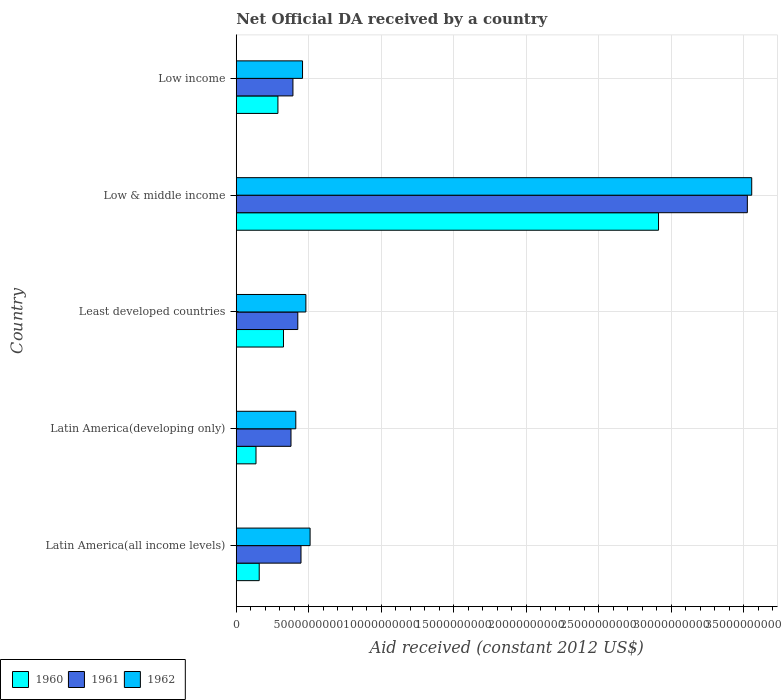How many groups of bars are there?
Your response must be concise. 5. Are the number of bars per tick equal to the number of legend labels?
Your response must be concise. Yes. What is the label of the 3rd group of bars from the top?
Keep it short and to the point. Least developed countries. In how many cases, is the number of bars for a given country not equal to the number of legend labels?
Your answer should be compact. 0. What is the net official development assistance aid received in 1962 in Low & middle income?
Provide a short and direct response. 3.56e+1. Across all countries, what is the maximum net official development assistance aid received in 1960?
Make the answer very short. 2.91e+1. Across all countries, what is the minimum net official development assistance aid received in 1960?
Make the answer very short. 1.36e+09. In which country was the net official development assistance aid received in 1961 maximum?
Give a very brief answer. Low & middle income. In which country was the net official development assistance aid received in 1960 minimum?
Ensure brevity in your answer.  Latin America(developing only). What is the total net official development assistance aid received in 1962 in the graph?
Your answer should be compact. 5.41e+1. What is the difference between the net official development assistance aid received in 1960 in Latin America(all income levels) and that in Least developed countries?
Make the answer very short. -1.68e+09. What is the difference between the net official development assistance aid received in 1962 in Latin America(developing only) and the net official development assistance aid received in 1961 in Low income?
Make the answer very short. 1.98e+08. What is the average net official development assistance aid received in 1961 per country?
Provide a succinct answer. 1.03e+1. What is the difference between the net official development assistance aid received in 1962 and net official development assistance aid received in 1960 in Low income?
Your answer should be compact. 1.70e+09. In how many countries, is the net official development assistance aid received in 1962 greater than 18000000000 US$?
Your response must be concise. 1. What is the ratio of the net official development assistance aid received in 1962 in Latin America(developing only) to that in Least developed countries?
Your response must be concise. 0.86. Is the net official development assistance aid received in 1962 in Latin America(developing only) less than that in Least developed countries?
Keep it short and to the point. Yes. Is the difference between the net official development assistance aid received in 1962 in Latin America(all income levels) and Low income greater than the difference between the net official development assistance aid received in 1960 in Latin America(all income levels) and Low income?
Offer a very short reply. Yes. What is the difference between the highest and the second highest net official development assistance aid received in 1962?
Keep it short and to the point. 3.05e+1. What is the difference between the highest and the lowest net official development assistance aid received in 1960?
Make the answer very short. 2.78e+1. In how many countries, is the net official development assistance aid received in 1960 greater than the average net official development assistance aid received in 1960 taken over all countries?
Your answer should be very brief. 1. Is the sum of the net official development assistance aid received in 1961 in Latin America(all income levels) and Low & middle income greater than the maximum net official development assistance aid received in 1960 across all countries?
Your answer should be very brief. Yes. What does the 1st bar from the bottom in Low income represents?
Provide a short and direct response. 1960. Is it the case that in every country, the sum of the net official development assistance aid received in 1961 and net official development assistance aid received in 1960 is greater than the net official development assistance aid received in 1962?
Keep it short and to the point. Yes. What is the difference between two consecutive major ticks on the X-axis?
Your answer should be very brief. 5.00e+09. Are the values on the major ticks of X-axis written in scientific E-notation?
Your answer should be compact. No. Does the graph contain grids?
Provide a succinct answer. Yes. How many legend labels are there?
Give a very brief answer. 3. What is the title of the graph?
Give a very brief answer. Net Official DA received by a country. Does "2000" appear as one of the legend labels in the graph?
Give a very brief answer. No. What is the label or title of the X-axis?
Your response must be concise. Aid received (constant 2012 US$). What is the Aid received (constant 2012 US$) of 1960 in Latin America(all income levels)?
Keep it short and to the point. 1.58e+09. What is the Aid received (constant 2012 US$) of 1961 in Latin America(all income levels)?
Your answer should be compact. 4.47e+09. What is the Aid received (constant 2012 US$) in 1962 in Latin America(all income levels)?
Your answer should be very brief. 5.09e+09. What is the Aid received (constant 2012 US$) of 1960 in Latin America(developing only)?
Your response must be concise. 1.36e+09. What is the Aid received (constant 2012 US$) in 1961 in Latin America(developing only)?
Provide a succinct answer. 3.78e+09. What is the Aid received (constant 2012 US$) in 1962 in Latin America(developing only)?
Make the answer very short. 4.11e+09. What is the Aid received (constant 2012 US$) of 1960 in Least developed countries?
Your response must be concise. 3.26e+09. What is the Aid received (constant 2012 US$) of 1961 in Least developed countries?
Your answer should be very brief. 4.25e+09. What is the Aid received (constant 2012 US$) of 1962 in Least developed countries?
Your answer should be compact. 4.80e+09. What is the Aid received (constant 2012 US$) of 1960 in Low & middle income?
Offer a very short reply. 2.91e+1. What is the Aid received (constant 2012 US$) in 1961 in Low & middle income?
Give a very brief answer. 3.53e+1. What is the Aid received (constant 2012 US$) of 1962 in Low & middle income?
Give a very brief answer. 3.56e+1. What is the Aid received (constant 2012 US$) of 1960 in Low income?
Your response must be concise. 2.87e+09. What is the Aid received (constant 2012 US$) in 1961 in Low income?
Make the answer very short. 3.91e+09. What is the Aid received (constant 2012 US$) of 1962 in Low income?
Make the answer very short. 4.57e+09. Across all countries, what is the maximum Aid received (constant 2012 US$) of 1960?
Your answer should be compact. 2.91e+1. Across all countries, what is the maximum Aid received (constant 2012 US$) of 1961?
Offer a very short reply. 3.53e+1. Across all countries, what is the maximum Aid received (constant 2012 US$) in 1962?
Give a very brief answer. 3.56e+1. Across all countries, what is the minimum Aid received (constant 2012 US$) in 1960?
Offer a very short reply. 1.36e+09. Across all countries, what is the minimum Aid received (constant 2012 US$) in 1961?
Offer a terse response. 3.78e+09. Across all countries, what is the minimum Aid received (constant 2012 US$) of 1962?
Provide a succinct answer. 4.11e+09. What is the total Aid received (constant 2012 US$) in 1960 in the graph?
Give a very brief answer. 3.82e+1. What is the total Aid received (constant 2012 US$) in 1961 in the graph?
Offer a very short reply. 5.17e+1. What is the total Aid received (constant 2012 US$) in 1962 in the graph?
Give a very brief answer. 5.41e+1. What is the difference between the Aid received (constant 2012 US$) in 1960 in Latin America(all income levels) and that in Latin America(developing only)?
Ensure brevity in your answer.  2.21e+08. What is the difference between the Aid received (constant 2012 US$) in 1961 in Latin America(all income levels) and that in Latin America(developing only)?
Your answer should be very brief. 6.90e+08. What is the difference between the Aid received (constant 2012 US$) of 1962 in Latin America(all income levels) and that in Latin America(developing only)?
Your answer should be compact. 9.87e+08. What is the difference between the Aid received (constant 2012 US$) in 1960 in Latin America(all income levels) and that in Least developed countries?
Your answer should be compact. -1.68e+09. What is the difference between the Aid received (constant 2012 US$) of 1961 in Latin America(all income levels) and that in Least developed countries?
Offer a very short reply. 2.22e+08. What is the difference between the Aid received (constant 2012 US$) of 1962 in Latin America(all income levels) and that in Least developed countries?
Provide a short and direct response. 2.91e+08. What is the difference between the Aid received (constant 2012 US$) in 1960 in Latin America(all income levels) and that in Low & middle income?
Offer a very short reply. -2.76e+1. What is the difference between the Aid received (constant 2012 US$) of 1961 in Latin America(all income levels) and that in Low & middle income?
Ensure brevity in your answer.  -3.08e+1. What is the difference between the Aid received (constant 2012 US$) in 1962 in Latin America(all income levels) and that in Low & middle income?
Offer a terse response. -3.05e+1. What is the difference between the Aid received (constant 2012 US$) in 1960 in Latin America(all income levels) and that in Low income?
Provide a succinct answer. -1.29e+09. What is the difference between the Aid received (constant 2012 US$) of 1961 in Latin America(all income levels) and that in Low income?
Provide a short and direct response. 5.57e+08. What is the difference between the Aid received (constant 2012 US$) in 1962 in Latin America(all income levels) and that in Low income?
Make the answer very short. 5.22e+08. What is the difference between the Aid received (constant 2012 US$) in 1960 in Latin America(developing only) and that in Least developed countries?
Give a very brief answer. -1.90e+09. What is the difference between the Aid received (constant 2012 US$) in 1961 in Latin America(developing only) and that in Least developed countries?
Your answer should be compact. -4.69e+08. What is the difference between the Aid received (constant 2012 US$) of 1962 in Latin America(developing only) and that in Least developed countries?
Offer a very short reply. -6.96e+08. What is the difference between the Aid received (constant 2012 US$) of 1960 in Latin America(developing only) and that in Low & middle income?
Give a very brief answer. -2.78e+1. What is the difference between the Aid received (constant 2012 US$) of 1961 in Latin America(developing only) and that in Low & middle income?
Provide a short and direct response. -3.15e+1. What is the difference between the Aid received (constant 2012 US$) of 1962 in Latin America(developing only) and that in Low & middle income?
Provide a short and direct response. -3.15e+1. What is the difference between the Aid received (constant 2012 US$) of 1960 in Latin America(developing only) and that in Low income?
Provide a succinct answer. -1.51e+09. What is the difference between the Aid received (constant 2012 US$) of 1961 in Latin America(developing only) and that in Low income?
Give a very brief answer. -1.33e+08. What is the difference between the Aid received (constant 2012 US$) in 1962 in Latin America(developing only) and that in Low income?
Keep it short and to the point. -4.65e+08. What is the difference between the Aid received (constant 2012 US$) of 1960 in Least developed countries and that in Low & middle income?
Your answer should be very brief. -2.59e+1. What is the difference between the Aid received (constant 2012 US$) in 1961 in Least developed countries and that in Low & middle income?
Make the answer very short. -3.10e+1. What is the difference between the Aid received (constant 2012 US$) of 1962 in Least developed countries and that in Low & middle income?
Make the answer very short. -3.08e+1. What is the difference between the Aid received (constant 2012 US$) in 1960 in Least developed countries and that in Low income?
Provide a succinct answer. 3.84e+08. What is the difference between the Aid received (constant 2012 US$) in 1961 in Least developed countries and that in Low income?
Your answer should be very brief. 3.36e+08. What is the difference between the Aid received (constant 2012 US$) in 1962 in Least developed countries and that in Low income?
Offer a very short reply. 2.31e+08. What is the difference between the Aid received (constant 2012 US$) in 1960 in Low & middle income and that in Low income?
Your answer should be very brief. 2.63e+1. What is the difference between the Aid received (constant 2012 US$) of 1961 in Low & middle income and that in Low income?
Offer a very short reply. 3.14e+1. What is the difference between the Aid received (constant 2012 US$) of 1962 in Low & middle income and that in Low income?
Ensure brevity in your answer.  3.10e+1. What is the difference between the Aid received (constant 2012 US$) of 1960 in Latin America(all income levels) and the Aid received (constant 2012 US$) of 1961 in Latin America(developing only)?
Your answer should be compact. -2.19e+09. What is the difference between the Aid received (constant 2012 US$) of 1960 in Latin America(all income levels) and the Aid received (constant 2012 US$) of 1962 in Latin America(developing only)?
Provide a succinct answer. -2.52e+09. What is the difference between the Aid received (constant 2012 US$) in 1961 in Latin America(all income levels) and the Aid received (constant 2012 US$) in 1962 in Latin America(developing only)?
Your response must be concise. 3.59e+08. What is the difference between the Aid received (constant 2012 US$) of 1960 in Latin America(all income levels) and the Aid received (constant 2012 US$) of 1961 in Least developed countries?
Provide a succinct answer. -2.66e+09. What is the difference between the Aid received (constant 2012 US$) in 1960 in Latin America(all income levels) and the Aid received (constant 2012 US$) in 1962 in Least developed countries?
Your response must be concise. -3.22e+09. What is the difference between the Aid received (constant 2012 US$) in 1961 in Latin America(all income levels) and the Aid received (constant 2012 US$) in 1962 in Least developed countries?
Your answer should be very brief. -3.37e+08. What is the difference between the Aid received (constant 2012 US$) in 1960 in Latin America(all income levels) and the Aid received (constant 2012 US$) in 1961 in Low & middle income?
Your response must be concise. -3.37e+1. What is the difference between the Aid received (constant 2012 US$) in 1960 in Latin America(all income levels) and the Aid received (constant 2012 US$) in 1962 in Low & middle income?
Keep it short and to the point. -3.40e+1. What is the difference between the Aid received (constant 2012 US$) of 1961 in Latin America(all income levels) and the Aid received (constant 2012 US$) of 1962 in Low & middle income?
Offer a terse response. -3.11e+1. What is the difference between the Aid received (constant 2012 US$) in 1960 in Latin America(all income levels) and the Aid received (constant 2012 US$) in 1961 in Low income?
Offer a terse response. -2.33e+09. What is the difference between the Aid received (constant 2012 US$) in 1960 in Latin America(all income levels) and the Aid received (constant 2012 US$) in 1962 in Low income?
Give a very brief answer. -2.99e+09. What is the difference between the Aid received (constant 2012 US$) of 1961 in Latin America(all income levels) and the Aid received (constant 2012 US$) of 1962 in Low income?
Provide a short and direct response. -1.05e+08. What is the difference between the Aid received (constant 2012 US$) of 1960 in Latin America(developing only) and the Aid received (constant 2012 US$) of 1961 in Least developed countries?
Your response must be concise. -2.88e+09. What is the difference between the Aid received (constant 2012 US$) of 1960 in Latin America(developing only) and the Aid received (constant 2012 US$) of 1962 in Least developed countries?
Your answer should be very brief. -3.44e+09. What is the difference between the Aid received (constant 2012 US$) of 1961 in Latin America(developing only) and the Aid received (constant 2012 US$) of 1962 in Least developed countries?
Offer a terse response. -1.03e+09. What is the difference between the Aid received (constant 2012 US$) in 1960 in Latin America(developing only) and the Aid received (constant 2012 US$) in 1961 in Low & middle income?
Keep it short and to the point. -3.39e+1. What is the difference between the Aid received (constant 2012 US$) in 1960 in Latin America(developing only) and the Aid received (constant 2012 US$) in 1962 in Low & middle income?
Your answer should be compact. -3.42e+1. What is the difference between the Aid received (constant 2012 US$) of 1961 in Latin America(developing only) and the Aid received (constant 2012 US$) of 1962 in Low & middle income?
Offer a terse response. -3.18e+1. What is the difference between the Aid received (constant 2012 US$) in 1960 in Latin America(developing only) and the Aid received (constant 2012 US$) in 1961 in Low income?
Your answer should be compact. -2.55e+09. What is the difference between the Aid received (constant 2012 US$) of 1960 in Latin America(developing only) and the Aid received (constant 2012 US$) of 1962 in Low income?
Provide a short and direct response. -3.21e+09. What is the difference between the Aid received (constant 2012 US$) of 1961 in Latin America(developing only) and the Aid received (constant 2012 US$) of 1962 in Low income?
Offer a very short reply. -7.96e+08. What is the difference between the Aid received (constant 2012 US$) of 1960 in Least developed countries and the Aid received (constant 2012 US$) of 1961 in Low & middle income?
Provide a short and direct response. -3.20e+1. What is the difference between the Aid received (constant 2012 US$) of 1960 in Least developed countries and the Aid received (constant 2012 US$) of 1962 in Low & middle income?
Ensure brevity in your answer.  -3.23e+1. What is the difference between the Aid received (constant 2012 US$) of 1961 in Least developed countries and the Aid received (constant 2012 US$) of 1962 in Low & middle income?
Offer a terse response. -3.13e+1. What is the difference between the Aid received (constant 2012 US$) in 1960 in Least developed countries and the Aid received (constant 2012 US$) in 1961 in Low income?
Offer a very short reply. -6.51e+08. What is the difference between the Aid received (constant 2012 US$) of 1960 in Least developed countries and the Aid received (constant 2012 US$) of 1962 in Low income?
Offer a terse response. -1.31e+09. What is the difference between the Aid received (constant 2012 US$) of 1961 in Least developed countries and the Aid received (constant 2012 US$) of 1962 in Low income?
Make the answer very short. -3.27e+08. What is the difference between the Aid received (constant 2012 US$) in 1960 in Low & middle income and the Aid received (constant 2012 US$) in 1961 in Low income?
Ensure brevity in your answer.  2.52e+1. What is the difference between the Aid received (constant 2012 US$) of 1960 in Low & middle income and the Aid received (constant 2012 US$) of 1962 in Low income?
Give a very brief answer. 2.46e+1. What is the difference between the Aid received (constant 2012 US$) in 1961 in Low & middle income and the Aid received (constant 2012 US$) in 1962 in Low income?
Offer a terse response. 3.07e+1. What is the average Aid received (constant 2012 US$) in 1960 per country?
Your answer should be very brief. 7.64e+09. What is the average Aid received (constant 2012 US$) in 1961 per country?
Your answer should be very brief. 1.03e+1. What is the average Aid received (constant 2012 US$) in 1962 per country?
Ensure brevity in your answer.  1.08e+1. What is the difference between the Aid received (constant 2012 US$) in 1960 and Aid received (constant 2012 US$) in 1961 in Latin America(all income levels)?
Make the answer very short. -2.88e+09. What is the difference between the Aid received (constant 2012 US$) of 1960 and Aid received (constant 2012 US$) of 1962 in Latin America(all income levels)?
Your response must be concise. -3.51e+09. What is the difference between the Aid received (constant 2012 US$) of 1961 and Aid received (constant 2012 US$) of 1962 in Latin America(all income levels)?
Offer a terse response. -6.27e+08. What is the difference between the Aid received (constant 2012 US$) of 1960 and Aid received (constant 2012 US$) of 1961 in Latin America(developing only)?
Your response must be concise. -2.41e+09. What is the difference between the Aid received (constant 2012 US$) of 1960 and Aid received (constant 2012 US$) of 1962 in Latin America(developing only)?
Provide a short and direct response. -2.75e+09. What is the difference between the Aid received (constant 2012 US$) of 1961 and Aid received (constant 2012 US$) of 1962 in Latin America(developing only)?
Your answer should be compact. -3.31e+08. What is the difference between the Aid received (constant 2012 US$) of 1960 and Aid received (constant 2012 US$) of 1961 in Least developed countries?
Give a very brief answer. -9.87e+08. What is the difference between the Aid received (constant 2012 US$) of 1960 and Aid received (constant 2012 US$) of 1962 in Least developed countries?
Your response must be concise. -1.54e+09. What is the difference between the Aid received (constant 2012 US$) in 1961 and Aid received (constant 2012 US$) in 1962 in Least developed countries?
Make the answer very short. -5.58e+08. What is the difference between the Aid received (constant 2012 US$) of 1960 and Aid received (constant 2012 US$) of 1961 in Low & middle income?
Keep it short and to the point. -6.13e+09. What is the difference between the Aid received (constant 2012 US$) in 1960 and Aid received (constant 2012 US$) in 1962 in Low & middle income?
Your answer should be compact. -6.43e+09. What is the difference between the Aid received (constant 2012 US$) in 1961 and Aid received (constant 2012 US$) in 1962 in Low & middle income?
Keep it short and to the point. -3.02e+08. What is the difference between the Aid received (constant 2012 US$) in 1960 and Aid received (constant 2012 US$) in 1961 in Low income?
Make the answer very short. -1.04e+09. What is the difference between the Aid received (constant 2012 US$) in 1960 and Aid received (constant 2012 US$) in 1962 in Low income?
Your answer should be very brief. -1.70e+09. What is the difference between the Aid received (constant 2012 US$) of 1961 and Aid received (constant 2012 US$) of 1962 in Low income?
Keep it short and to the point. -6.62e+08. What is the ratio of the Aid received (constant 2012 US$) in 1960 in Latin America(all income levels) to that in Latin America(developing only)?
Make the answer very short. 1.16. What is the ratio of the Aid received (constant 2012 US$) in 1961 in Latin America(all income levels) to that in Latin America(developing only)?
Make the answer very short. 1.18. What is the ratio of the Aid received (constant 2012 US$) in 1962 in Latin America(all income levels) to that in Latin America(developing only)?
Provide a short and direct response. 1.24. What is the ratio of the Aid received (constant 2012 US$) in 1960 in Latin America(all income levels) to that in Least developed countries?
Your response must be concise. 0.49. What is the ratio of the Aid received (constant 2012 US$) of 1961 in Latin America(all income levels) to that in Least developed countries?
Provide a succinct answer. 1.05. What is the ratio of the Aid received (constant 2012 US$) in 1962 in Latin America(all income levels) to that in Least developed countries?
Your response must be concise. 1.06. What is the ratio of the Aid received (constant 2012 US$) of 1960 in Latin America(all income levels) to that in Low & middle income?
Ensure brevity in your answer.  0.05. What is the ratio of the Aid received (constant 2012 US$) of 1961 in Latin America(all income levels) to that in Low & middle income?
Offer a very short reply. 0.13. What is the ratio of the Aid received (constant 2012 US$) of 1962 in Latin America(all income levels) to that in Low & middle income?
Provide a short and direct response. 0.14. What is the ratio of the Aid received (constant 2012 US$) in 1960 in Latin America(all income levels) to that in Low income?
Offer a very short reply. 0.55. What is the ratio of the Aid received (constant 2012 US$) of 1961 in Latin America(all income levels) to that in Low income?
Provide a succinct answer. 1.14. What is the ratio of the Aid received (constant 2012 US$) in 1962 in Latin America(all income levels) to that in Low income?
Make the answer very short. 1.11. What is the ratio of the Aid received (constant 2012 US$) of 1960 in Latin America(developing only) to that in Least developed countries?
Your answer should be very brief. 0.42. What is the ratio of the Aid received (constant 2012 US$) in 1961 in Latin America(developing only) to that in Least developed countries?
Your answer should be compact. 0.89. What is the ratio of the Aid received (constant 2012 US$) in 1962 in Latin America(developing only) to that in Least developed countries?
Your response must be concise. 0.86. What is the ratio of the Aid received (constant 2012 US$) of 1960 in Latin America(developing only) to that in Low & middle income?
Provide a succinct answer. 0.05. What is the ratio of the Aid received (constant 2012 US$) of 1961 in Latin America(developing only) to that in Low & middle income?
Your answer should be compact. 0.11. What is the ratio of the Aid received (constant 2012 US$) of 1962 in Latin America(developing only) to that in Low & middle income?
Offer a terse response. 0.12. What is the ratio of the Aid received (constant 2012 US$) of 1960 in Latin America(developing only) to that in Low income?
Your answer should be compact. 0.47. What is the ratio of the Aid received (constant 2012 US$) in 1961 in Latin America(developing only) to that in Low income?
Your response must be concise. 0.97. What is the ratio of the Aid received (constant 2012 US$) in 1962 in Latin America(developing only) to that in Low income?
Your answer should be very brief. 0.9. What is the ratio of the Aid received (constant 2012 US$) of 1960 in Least developed countries to that in Low & middle income?
Your answer should be compact. 0.11. What is the ratio of the Aid received (constant 2012 US$) in 1961 in Least developed countries to that in Low & middle income?
Ensure brevity in your answer.  0.12. What is the ratio of the Aid received (constant 2012 US$) of 1962 in Least developed countries to that in Low & middle income?
Offer a terse response. 0.14. What is the ratio of the Aid received (constant 2012 US$) of 1960 in Least developed countries to that in Low income?
Your response must be concise. 1.13. What is the ratio of the Aid received (constant 2012 US$) in 1961 in Least developed countries to that in Low income?
Your response must be concise. 1.09. What is the ratio of the Aid received (constant 2012 US$) in 1962 in Least developed countries to that in Low income?
Make the answer very short. 1.05. What is the ratio of the Aid received (constant 2012 US$) of 1960 in Low & middle income to that in Low income?
Offer a very short reply. 10.13. What is the ratio of the Aid received (constant 2012 US$) in 1961 in Low & middle income to that in Low income?
Ensure brevity in your answer.  9.02. What is the ratio of the Aid received (constant 2012 US$) of 1962 in Low & middle income to that in Low income?
Keep it short and to the point. 7.78. What is the difference between the highest and the second highest Aid received (constant 2012 US$) in 1960?
Give a very brief answer. 2.59e+1. What is the difference between the highest and the second highest Aid received (constant 2012 US$) of 1961?
Provide a succinct answer. 3.08e+1. What is the difference between the highest and the second highest Aid received (constant 2012 US$) of 1962?
Your response must be concise. 3.05e+1. What is the difference between the highest and the lowest Aid received (constant 2012 US$) of 1960?
Make the answer very short. 2.78e+1. What is the difference between the highest and the lowest Aid received (constant 2012 US$) of 1961?
Offer a very short reply. 3.15e+1. What is the difference between the highest and the lowest Aid received (constant 2012 US$) of 1962?
Your answer should be compact. 3.15e+1. 